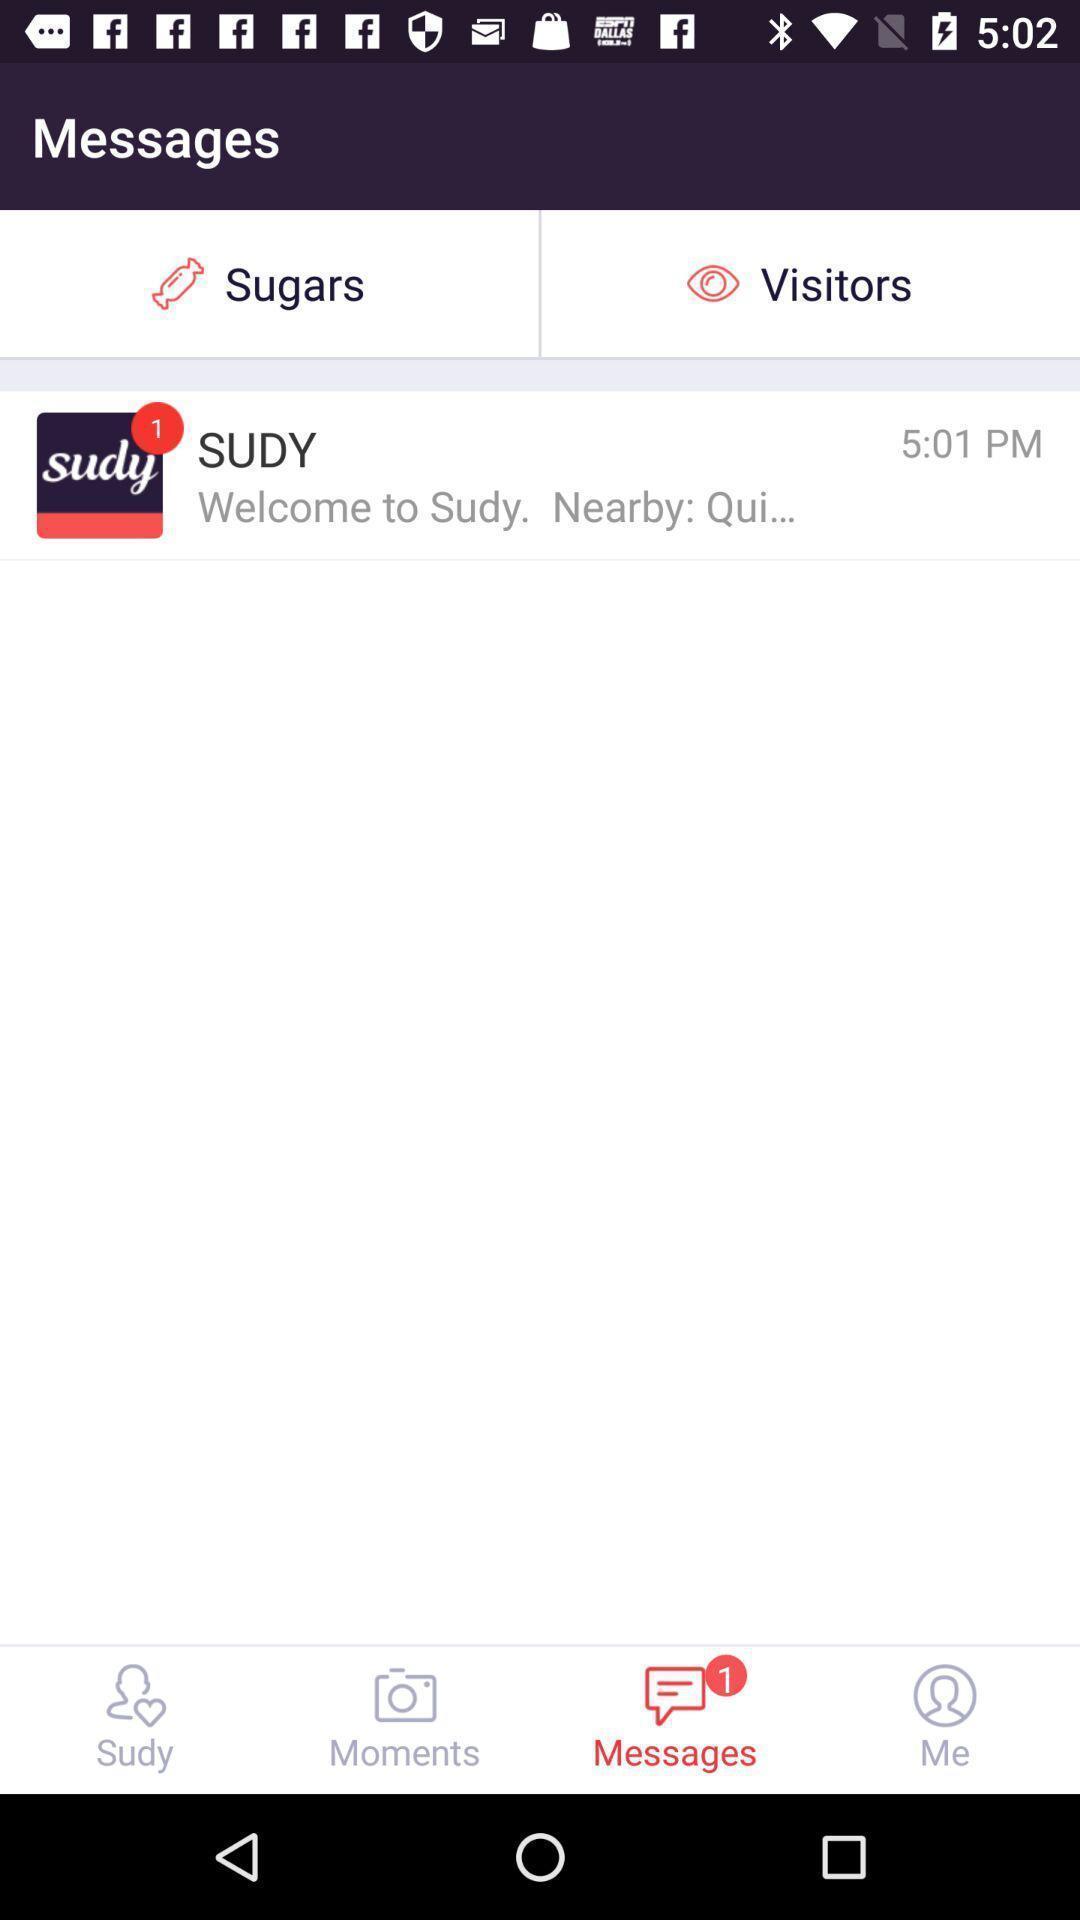Tell me about the visual elements in this screen capture. Screen displaying the messages page. 